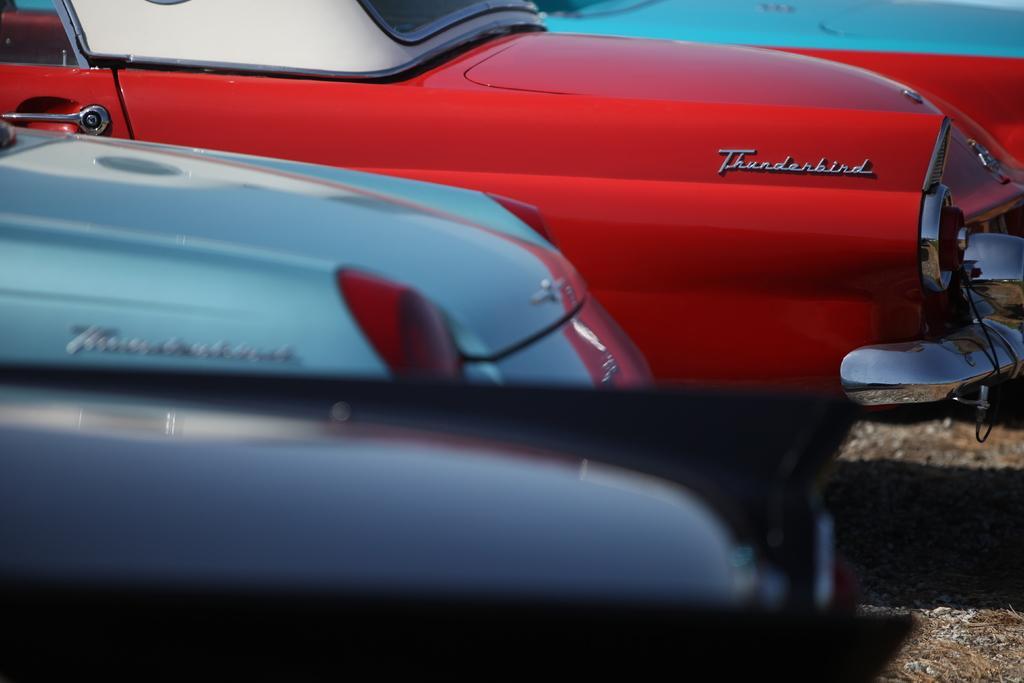Could you give a brief overview of what you see in this image? In this image we can see some different colors and models of cars. 